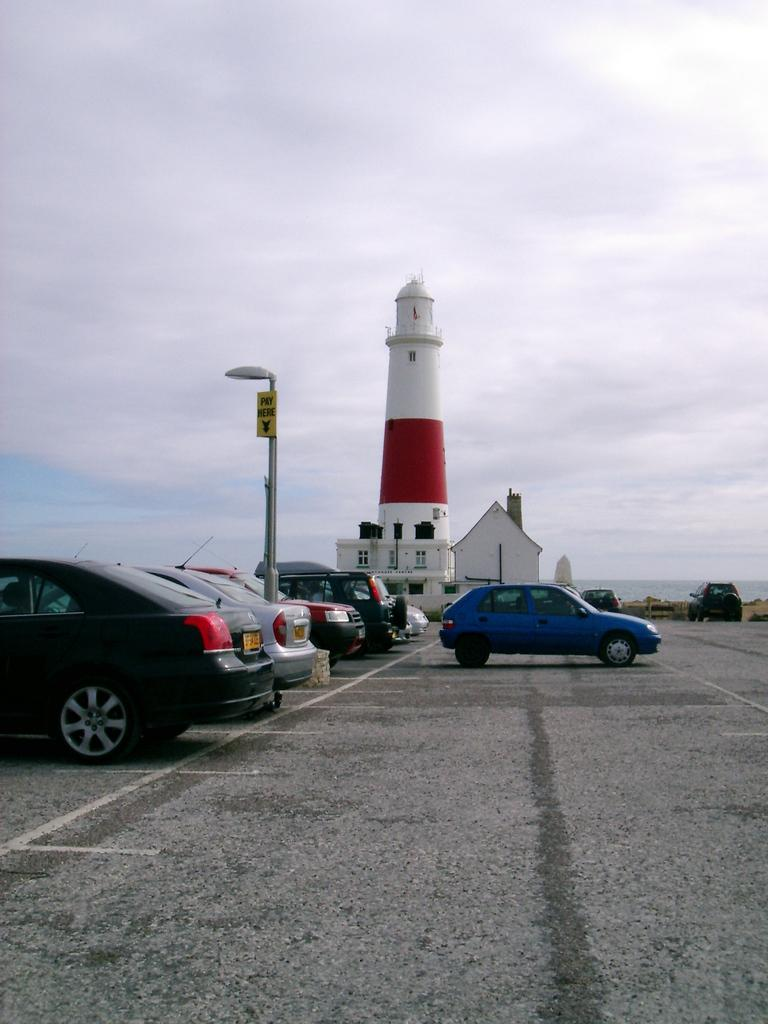What can be seen on the surface in the image? There are vehicles on the surface in the image. What is attached to the pole in the image? There is a light and a board on the pole in the image. What is visible in the background of the image? Water, sky with clouds, and a lighthouse are visible in the background of the image. What type of hall can be seen in the image? There is no hall present in the image. How quiet is the environment in the image? The image does not provide information about the noise level or the environment's quietness. 